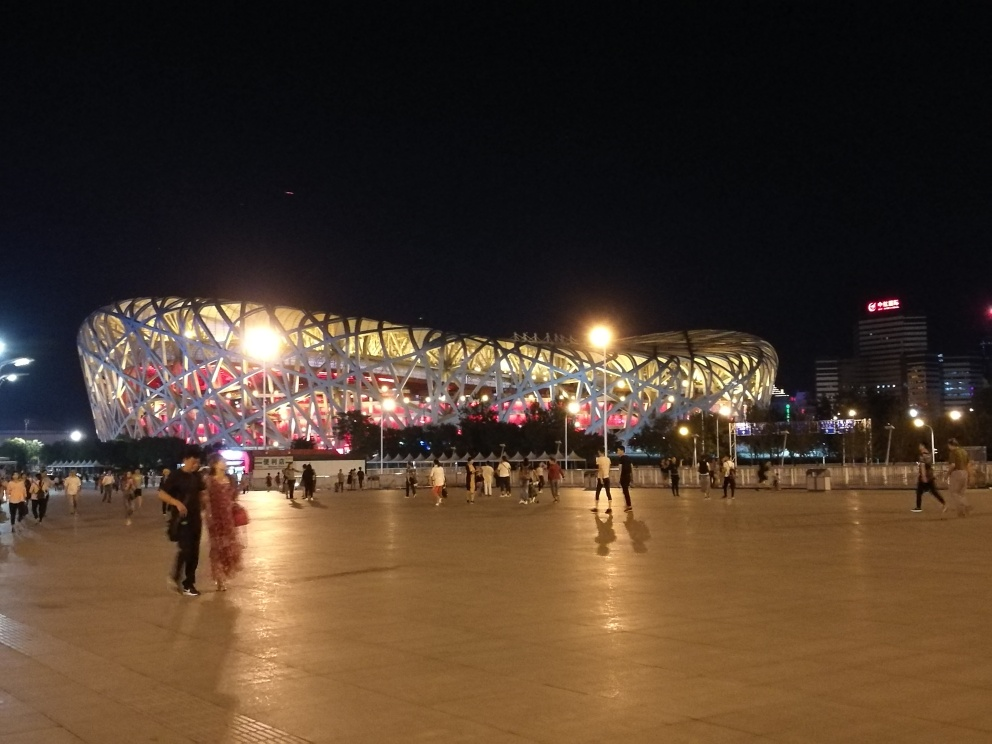What might be the purpose of this bright and elaborate structure? Given its grand design and lighting, this structure appears to be a significant cultural or sports facility, possibly a stadium that becomes a focal point during evening events. Is this a famous landmark? While I'm unable to confirm the name or exact details, structures like this are often iconic landmarks in their cities and can be renowned worldwide. 